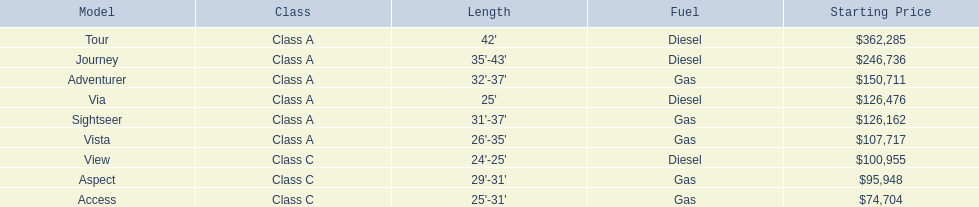What do the prices entail? $362,285, $246,736, $150,711, $126,476, $126,162, $107,717, $100,955, $95,948, $74,704. What's the maximum price? $362,285. Which model possesses this price? Tour. 